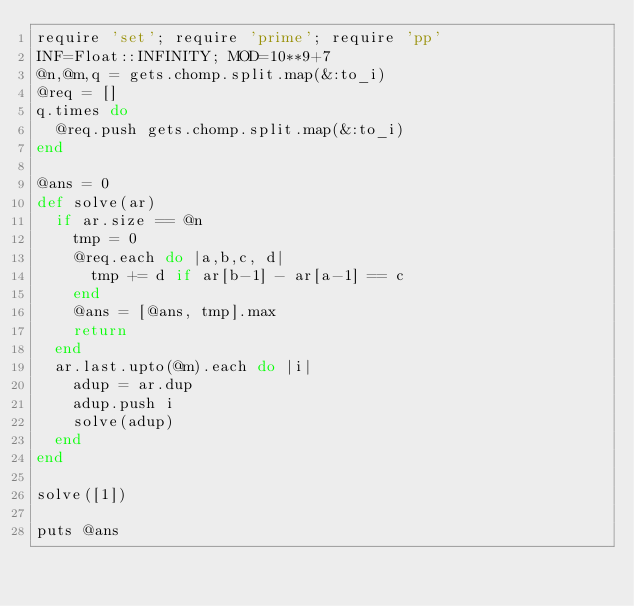<code> <loc_0><loc_0><loc_500><loc_500><_Ruby_>require 'set'; require 'prime'; require 'pp'
INF=Float::INFINITY; MOD=10**9+7
@n,@m,q = gets.chomp.split.map(&:to_i)
@req = []
q.times do
  @req.push gets.chomp.split.map(&:to_i)
end

@ans = 0
def solve(ar)
  if ar.size == @n
    tmp = 0
    @req.each do |a,b,c, d|
      tmp += d if ar[b-1] - ar[a-1] == c
    end
    @ans = [@ans, tmp].max
    return
  end
  ar.last.upto(@m).each do |i|
    adup = ar.dup
    adup.push i
    solve(adup)
  end
end

solve([1])

puts @ans


</code> 